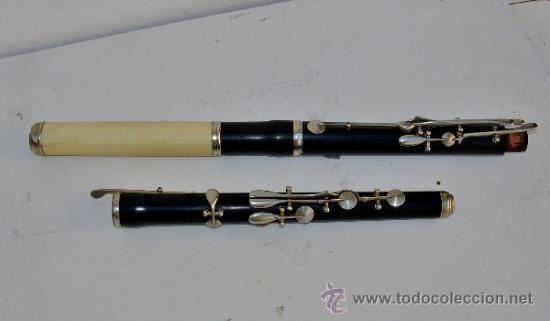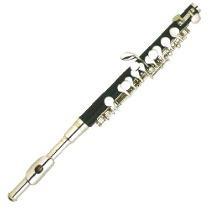The first image is the image on the left, the second image is the image on the right. Examine the images to the left and right. Is the description "The clarinet in the image on the left is taken apart into pieces." accurate? Answer yes or no. Yes. The first image is the image on the left, the second image is the image on the right. For the images displayed, is the sentence "The left image includes at least two black tube-shaped flute parts displayed horizontally but spaced apart." factually correct? Answer yes or no. Yes. 